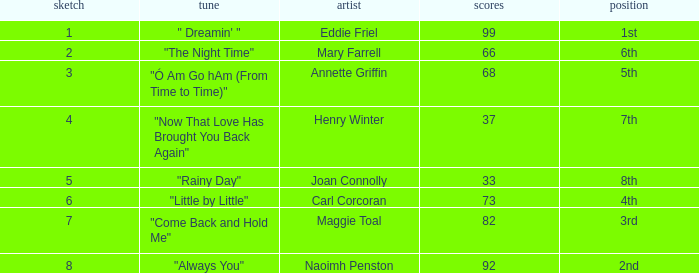What is the lowest points when the ranking is 1st? 99.0. 